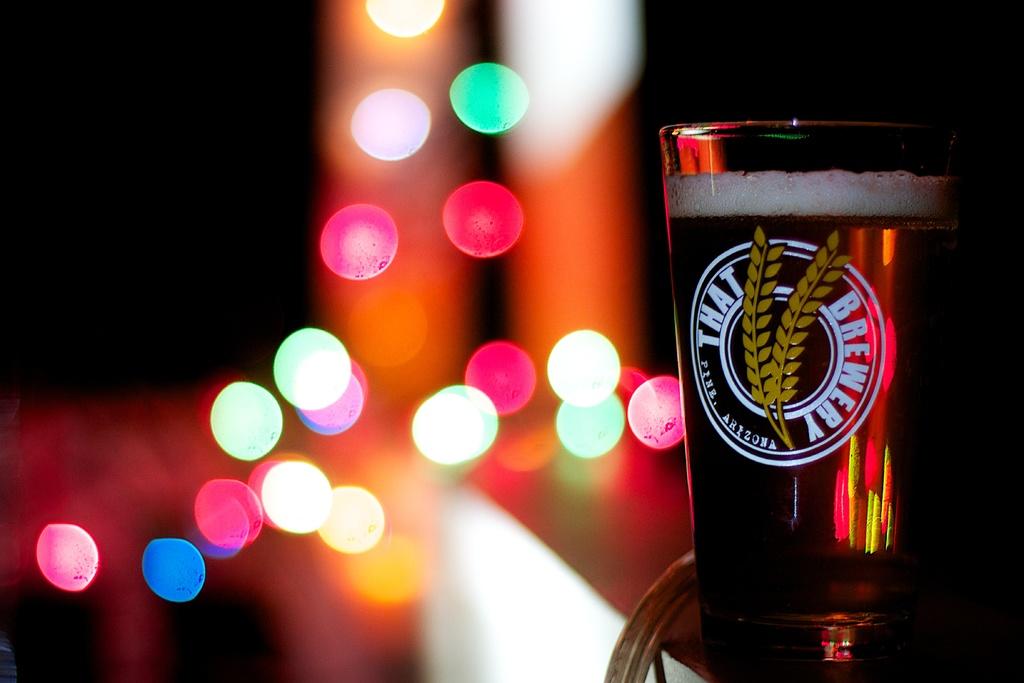In what state is that brewery?
Give a very brief answer. Arizona. What brewery is that?
Offer a very short reply. That brewery. 